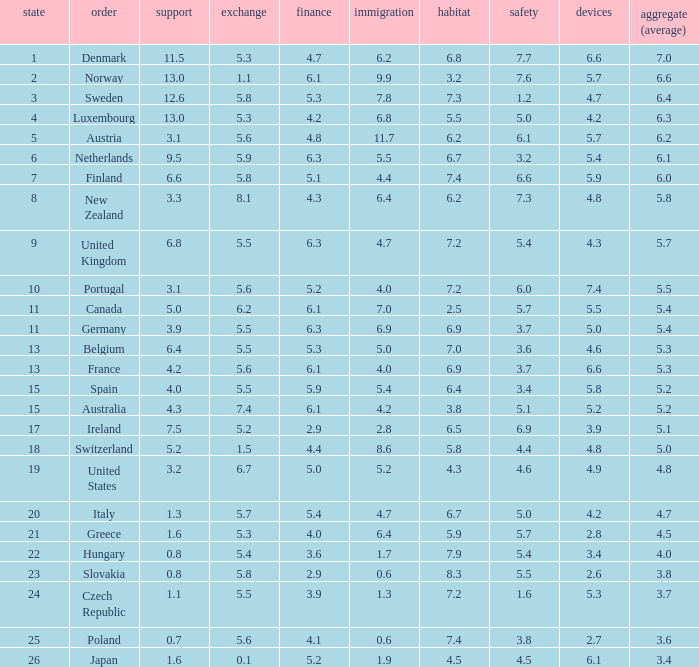What country has a 5.5 mark for security? Slovakia. 